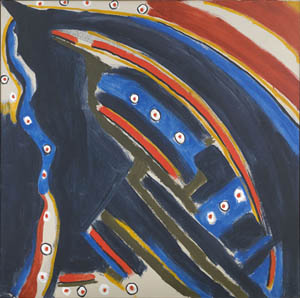Let's imagine this image as part of a fantasy universe. What kind of civilization would exist around it? In the fantastical universe where this abstract image exists as a cosmic beacon, a highly advanced and spiritual civilization, the Celestine, thrives around it. The Celestine believe that the image is a divine artifact, a celestial map guiding them through the vast expanse of their world and beyond. Their society is built around harmony with the cosmos, valuing knowledge, artistic expression, and deep spiritual insight.

Their architecture mimics the fluid and dynamic patterns of the image, with flowing structures adorned with vibrant colors and illuminated by orbs of light. The Celestine practice a unique form of art, communication, and meditation based on the interplay of colors and abstract forms. They interpret the image’s scattered dots as portals to other dimensions, embarking on grand explorations and spiritual pilgrimages to uncover the mysteries of the universe.

In their temples, scholars and mystics gather to decode the cosmic messages believed to be embedded within the image, constantly discovering new realms of knowledge and existence. The Celestine civilization thrives on unity and enlightenment, always seeking to align themselves with the deeper truths represented by the abstract shapes and celestial patterns in their revered cosmic artifact. 